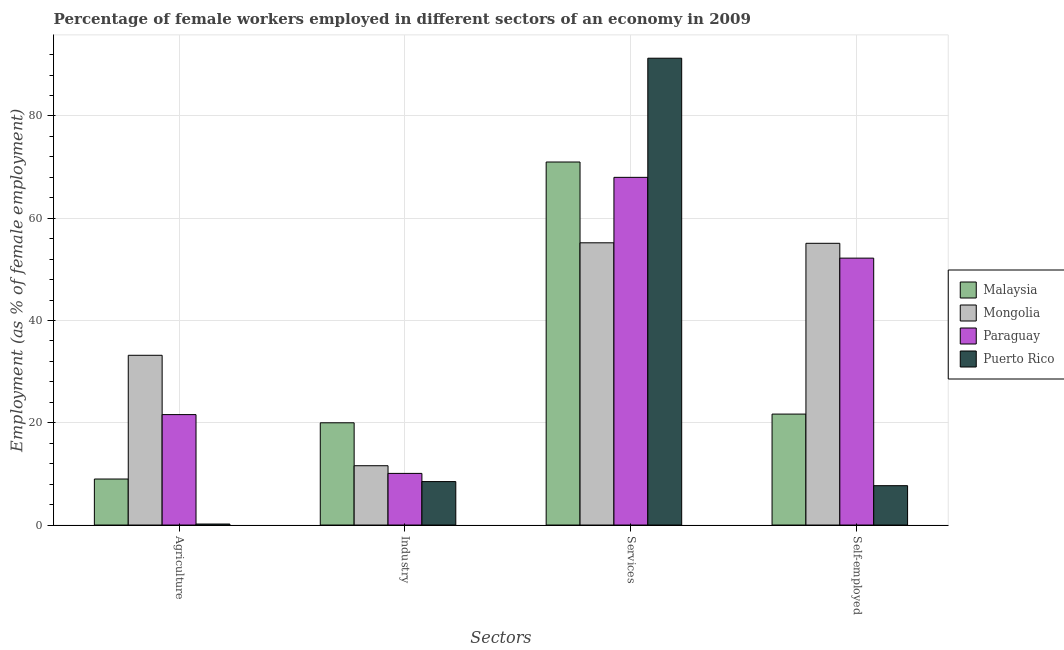How many groups of bars are there?
Offer a terse response. 4. Are the number of bars on each tick of the X-axis equal?
Offer a very short reply. Yes. How many bars are there on the 4th tick from the right?
Your answer should be very brief. 4. What is the label of the 4th group of bars from the left?
Ensure brevity in your answer.  Self-employed. Across all countries, what is the minimum percentage of self employed female workers?
Make the answer very short. 7.7. In which country was the percentage of self employed female workers maximum?
Your answer should be very brief. Mongolia. In which country was the percentage of self employed female workers minimum?
Provide a short and direct response. Puerto Rico. What is the total percentage of female workers in industry in the graph?
Offer a terse response. 50.2. What is the difference between the percentage of female workers in services in Paraguay and that in Puerto Rico?
Provide a succinct answer. -23.3. What is the difference between the percentage of female workers in services in Puerto Rico and the percentage of self employed female workers in Mongolia?
Provide a succinct answer. 36.2. What is the average percentage of female workers in services per country?
Make the answer very short. 71.38. What is the difference between the percentage of female workers in agriculture and percentage of female workers in services in Paraguay?
Provide a succinct answer. -46.4. What is the ratio of the percentage of self employed female workers in Malaysia to that in Mongolia?
Ensure brevity in your answer.  0.39. What is the difference between the highest and the second highest percentage of self employed female workers?
Your answer should be compact. 2.9. What is the difference between the highest and the lowest percentage of female workers in agriculture?
Provide a succinct answer. 33. What does the 3rd bar from the left in Industry represents?
Keep it short and to the point. Paraguay. What does the 4th bar from the right in Self-employed represents?
Offer a terse response. Malaysia. Is it the case that in every country, the sum of the percentage of female workers in agriculture and percentage of female workers in industry is greater than the percentage of female workers in services?
Offer a terse response. No. How many bars are there?
Offer a very short reply. 16. What is the difference between two consecutive major ticks on the Y-axis?
Offer a terse response. 20. Are the values on the major ticks of Y-axis written in scientific E-notation?
Your response must be concise. No. What is the title of the graph?
Your answer should be very brief. Percentage of female workers employed in different sectors of an economy in 2009. What is the label or title of the X-axis?
Your response must be concise. Sectors. What is the label or title of the Y-axis?
Give a very brief answer. Employment (as % of female employment). What is the Employment (as % of female employment) of Mongolia in Agriculture?
Offer a very short reply. 33.2. What is the Employment (as % of female employment) of Paraguay in Agriculture?
Make the answer very short. 21.6. What is the Employment (as % of female employment) of Puerto Rico in Agriculture?
Provide a short and direct response. 0.2. What is the Employment (as % of female employment) in Mongolia in Industry?
Make the answer very short. 11.6. What is the Employment (as % of female employment) in Paraguay in Industry?
Offer a very short reply. 10.1. What is the Employment (as % of female employment) of Mongolia in Services?
Keep it short and to the point. 55.2. What is the Employment (as % of female employment) of Puerto Rico in Services?
Provide a short and direct response. 91.3. What is the Employment (as % of female employment) in Malaysia in Self-employed?
Offer a terse response. 21.7. What is the Employment (as % of female employment) of Mongolia in Self-employed?
Give a very brief answer. 55.1. What is the Employment (as % of female employment) in Paraguay in Self-employed?
Ensure brevity in your answer.  52.2. What is the Employment (as % of female employment) of Puerto Rico in Self-employed?
Your response must be concise. 7.7. Across all Sectors, what is the maximum Employment (as % of female employment) of Malaysia?
Make the answer very short. 71. Across all Sectors, what is the maximum Employment (as % of female employment) in Mongolia?
Your response must be concise. 55.2. Across all Sectors, what is the maximum Employment (as % of female employment) in Paraguay?
Keep it short and to the point. 68. Across all Sectors, what is the maximum Employment (as % of female employment) of Puerto Rico?
Provide a short and direct response. 91.3. Across all Sectors, what is the minimum Employment (as % of female employment) of Malaysia?
Provide a short and direct response. 9. Across all Sectors, what is the minimum Employment (as % of female employment) of Mongolia?
Offer a very short reply. 11.6. Across all Sectors, what is the minimum Employment (as % of female employment) in Paraguay?
Your response must be concise. 10.1. Across all Sectors, what is the minimum Employment (as % of female employment) in Puerto Rico?
Make the answer very short. 0.2. What is the total Employment (as % of female employment) of Malaysia in the graph?
Provide a short and direct response. 121.7. What is the total Employment (as % of female employment) in Mongolia in the graph?
Offer a terse response. 155.1. What is the total Employment (as % of female employment) of Paraguay in the graph?
Your response must be concise. 151.9. What is the total Employment (as % of female employment) of Puerto Rico in the graph?
Provide a succinct answer. 107.7. What is the difference between the Employment (as % of female employment) of Malaysia in Agriculture and that in Industry?
Ensure brevity in your answer.  -11. What is the difference between the Employment (as % of female employment) in Mongolia in Agriculture and that in Industry?
Offer a very short reply. 21.6. What is the difference between the Employment (as % of female employment) of Puerto Rico in Agriculture and that in Industry?
Your response must be concise. -8.3. What is the difference between the Employment (as % of female employment) of Malaysia in Agriculture and that in Services?
Your response must be concise. -62. What is the difference between the Employment (as % of female employment) of Paraguay in Agriculture and that in Services?
Offer a very short reply. -46.4. What is the difference between the Employment (as % of female employment) of Puerto Rico in Agriculture and that in Services?
Give a very brief answer. -91.1. What is the difference between the Employment (as % of female employment) of Malaysia in Agriculture and that in Self-employed?
Make the answer very short. -12.7. What is the difference between the Employment (as % of female employment) of Mongolia in Agriculture and that in Self-employed?
Make the answer very short. -21.9. What is the difference between the Employment (as % of female employment) in Paraguay in Agriculture and that in Self-employed?
Provide a short and direct response. -30.6. What is the difference between the Employment (as % of female employment) of Malaysia in Industry and that in Services?
Provide a succinct answer. -51. What is the difference between the Employment (as % of female employment) in Mongolia in Industry and that in Services?
Offer a very short reply. -43.6. What is the difference between the Employment (as % of female employment) of Paraguay in Industry and that in Services?
Keep it short and to the point. -57.9. What is the difference between the Employment (as % of female employment) in Puerto Rico in Industry and that in Services?
Give a very brief answer. -82.8. What is the difference between the Employment (as % of female employment) of Mongolia in Industry and that in Self-employed?
Provide a succinct answer. -43.5. What is the difference between the Employment (as % of female employment) in Paraguay in Industry and that in Self-employed?
Ensure brevity in your answer.  -42.1. What is the difference between the Employment (as % of female employment) of Puerto Rico in Industry and that in Self-employed?
Provide a succinct answer. 0.8. What is the difference between the Employment (as % of female employment) in Malaysia in Services and that in Self-employed?
Keep it short and to the point. 49.3. What is the difference between the Employment (as % of female employment) of Mongolia in Services and that in Self-employed?
Your response must be concise. 0.1. What is the difference between the Employment (as % of female employment) of Paraguay in Services and that in Self-employed?
Make the answer very short. 15.8. What is the difference between the Employment (as % of female employment) of Puerto Rico in Services and that in Self-employed?
Give a very brief answer. 83.6. What is the difference between the Employment (as % of female employment) in Malaysia in Agriculture and the Employment (as % of female employment) in Mongolia in Industry?
Keep it short and to the point. -2.6. What is the difference between the Employment (as % of female employment) of Mongolia in Agriculture and the Employment (as % of female employment) of Paraguay in Industry?
Ensure brevity in your answer.  23.1. What is the difference between the Employment (as % of female employment) of Mongolia in Agriculture and the Employment (as % of female employment) of Puerto Rico in Industry?
Make the answer very short. 24.7. What is the difference between the Employment (as % of female employment) in Paraguay in Agriculture and the Employment (as % of female employment) in Puerto Rico in Industry?
Offer a very short reply. 13.1. What is the difference between the Employment (as % of female employment) of Malaysia in Agriculture and the Employment (as % of female employment) of Mongolia in Services?
Your answer should be compact. -46.2. What is the difference between the Employment (as % of female employment) in Malaysia in Agriculture and the Employment (as % of female employment) in Paraguay in Services?
Your answer should be compact. -59. What is the difference between the Employment (as % of female employment) of Malaysia in Agriculture and the Employment (as % of female employment) of Puerto Rico in Services?
Offer a very short reply. -82.3. What is the difference between the Employment (as % of female employment) in Mongolia in Agriculture and the Employment (as % of female employment) in Paraguay in Services?
Keep it short and to the point. -34.8. What is the difference between the Employment (as % of female employment) of Mongolia in Agriculture and the Employment (as % of female employment) of Puerto Rico in Services?
Provide a short and direct response. -58.1. What is the difference between the Employment (as % of female employment) of Paraguay in Agriculture and the Employment (as % of female employment) of Puerto Rico in Services?
Ensure brevity in your answer.  -69.7. What is the difference between the Employment (as % of female employment) in Malaysia in Agriculture and the Employment (as % of female employment) in Mongolia in Self-employed?
Offer a terse response. -46.1. What is the difference between the Employment (as % of female employment) of Malaysia in Agriculture and the Employment (as % of female employment) of Paraguay in Self-employed?
Give a very brief answer. -43.2. What is the difference between the Employment (as % of female employment) in Mongolia in Agriculture and the Employment (as % of female employment) in Paraguay in Self-employed?
Ensure brevity in your answer.  -19. What is the difference between the Employment (as % of female employment) of Mongolia in Agriculture and the Employment (as % of female employment) of Puerto Rico in Self-employed?
Keep it short and to the point. 25.5. What is the difference between the Employment (as % of female employment) in Malaysia in Industry and the Employment (as % of female employment) in Mongolia in Services?
Keep it short and to the point. -35.2. What is the difference between the Employment (as % of female employment) in Malaysia in Industry and the Employment (as % of female employment) in Paraguay in Services?
Give a very brief answer. -48. What is the difference between the Employment (as % of female employment) of Malaysia in Industry and the Employment (as % of female employment) of Puerto Rico in Services?
Give a very brief answer. -71.3. What is the difference between the Employment (as % of female employment) in Mongolia in Industry and the Employment (as % of female employment) in Paraguay in Services?
Offer a terse response. -56.4. What is the difference between the Employment (as % of female employment) of Mongolia in Industry and the Employment (as % of female employment) of Puerto Rico in Services?
Ensure brevity in your answer.  -79.7. What is the difference between the Employment (as % of female employment) in Paraguay in Industry and the Employment (as % of female employment) in Puerto Rico in Services?
Offer a terse response. -81.2. What is the difference between the Employment (as % of female employment) in Malaysia in Industry and the Employment (as % of female employment) in Mongolia in Self-employed?
Make the answer very short. -35.1. What is the difference between the Employment (as % of female employment) in Malaysia in Industry and the Employment (as % of female employment) in Paraguay in Self-employed?
Your answer should be very brief. -32.2. What is the difference between the Employment (as % of female employment) in Malaysia in Industry and the Employment (as % of female employment) in Puerto Rico in Self-employed?
Your response must be concise. 12.3. What is the difference between the Employment (as % of female employment) in Mongolia in Industry and the Employment (as % of female employment) in Paraguay in Self-employed?
Provide a succinct answer. -40.6. What is the difference between the Employment (as % of female employment) in Mongolia in Industry and the Employment (as % of female employment) in Puerto Rico in Self-employed?
Your response must be concise. 3.9. What is the difference between the Employment (as % of female employment) of Paraguay in Industry and the Employment (as % of female employment) of Puerto Rico in Self-employed?
Offer a terse response. 2.4. What is the difference between the Employment (as % of female employment) in Malaysia in Services and the Employment (as % of female employment) in Puerto Rico in Self-employed?
Your response must be concise. 63.3. What is the difference between the Employment (as % of female employment) of Mongolia in Services and the Employment (as % of female employment) of Paraguay in Self-employed?
Provide a short and direct response. 3. What is the difference between the Employment (as % of female employment) of Mongolia in Services and the Employment (as % of female employment) of Puerto Rico in Self-employed?
Offer a very short reply. 47.5. What is the difference between the Employment (as % of female employment) of Paraguay in Services and the Employment (as % of female employment) of Puerto Rico in Self-employed?
Keep it short and to the point. 60.3. What is the average Employment (as % of female employment) of Malaysia per Sectors?
Your answer should be compact. 30.43. What is the average Employment (as % of female employment) of Mongolia per Sectors?
Ensure brevity in your answer.  38.77. What is the average Employment (as % of female employment) of Paraguay per Sectors?
Make the answer very short. 37.98. What is the average Employment (as % of female employment) of Puerto Rico per Sectors?
Make the answer very short. 26.93. What is the difference between the Employment (as % of female employment) of Malaysia and Employment (as % of female employment) of Mongolia in Agriculture?
Your answer should be very brief. -24.2. What is the difference between the Employment (as % of female employment) in Mongolia and Employment (as % of female employment) in Paraguay in Agriculture?
Your answer should be very brief. 11.6. What is the difference between the Employment (as % of female employment) of Mongolia and Employment (as % of female employment) of Puerto Rico in Agriculture?
Your answer should be compact. 33. What is the difference between the Employment (as % of female employment) in Paraguay and Employment (as % of female employment) in Puerto Rico in Agriculture?
Your answer should be compact. 21.4. What is the difference between the Employment (as % of female employment) in Malaysia and Employment (as % of female employment) in Puerto Rico in Industry?
Make the answer very short. 11.5. What is the difference between the Employment (as % of female employment) in Mongolia and Employment (as % of female employment) in Paraguay in Industry?
Keep it short and to the point. 1.5. What is the difference between the Employment (as % of female employment) in Mongolia and Employment (as % of female employment) in Puerto Rico in Industry?
Your response must be concise. 3.1. What is the difference between the Employment (as % of female employment) of Malaysia and Employment (as % of female employment) of Puerto Rico in Services?
Provide a short and direct response. -20.3. What is the difference between the Employment (as % of female employment) of Mongolia and Employment (as % of female employment) of Puerto Rico in Services?
Your answer should be very brief. -36.1. What is the difference between the Employment (as % of female employment) in Paraguay and Employment (as % of female employment) in Puerto Rico in Services?
Make the answer very short. -23.3. What is the difference between the Employment (as % of female employment) of Malaysia and Employment (as % of female employment) of Mongolia in Self-employed?
Make the answer very short. -33.4. What is the difference between the Employment (as % of female employment) of Malaysia and Employment (as % of female employment) of Paraguay in Self-employed?
Offer a terse response. -30.5. What is the difference between the Employment (as % of female employment) of Mongolia and Employment (as % of female employment) of Puerto Rico in Self-employed?
Give a very brief answer. 47.4. What is the difference between the Employment (as % of female employment) in Paraguay and Employment (as % of female employment) in Puerto Rico in Self-employed?
Your answer should be compact. 44.5. What is the ratio of the Employment (as % of female employment) in Malaysia in Agriculture to that in Industry?
Your answer should be very brief. 0.45. What is the ratio of the Employment (as % of female employment) of Mongolia in Agriculture to that in Industry?
Your answer should be compact. 2.86. What is the ratio of the Employment (as % of female employment) in Paraguay in Agriculture to that in Industry?
Your answer should be compact. 2.14. What is the ratio of the Employment (as % of female employment) of Puerto Rico in Agriculture to that in Industry?
Make the answer very short. 0.02. What is the ratio of the Employment (as % of female employment) of Malaysia in Agriculture to that in Services?
Keep it short and to the point. 0.13. What is the ratio of the Employment (as % of female employment) in Mongolia in Agriculture to that in Services?
Ensure brevity in your answer.  0.6. What is the ratio of the Employment (as % of female employment) of Paraguay in Agriculture to that in Services?
Ensure brevity in your answer.  0.32. What is the ratio of the Employment (as % of female employment) of Puerto Rico in Agriculture to that in Services?
Your answer should be very brief. 0. What is the ratio of the Employment (as % of female employment) in Malaysia in Agriculture to that in Self-employed?
Offer a terse response. 0.41. What is the ratio of the Employment (as % of female employment) of Mongolia in Agriculture to that in Self-employed?
Give a very brief answer. 0.6. What is the ratio of the Employment (as % of female employment) of Paraguay in Agriculture to that in Self-employed?
Provide a short and direct response. 0.41. What is the ratio of the Employment (as % of female employment) of Puerto Rico in Agriculture to that in Self-employed?
Give a very brief answer. 0.03. What is the ratio of the Employment (as % of female employment) in Malaysia in Industry to that in Services?
Your answer should be compact. 0.28. What is the ratio of the Employment (as % of female employment) of Mongolia in Industry to that in Services?
Ensure brevity in your answer.  0.21. What is the ratio of the Employment (as % of female employment) of Paraguay in Industry to that in Services?
Your answer should be very brief. 0.15. What is the ratio of the Employment (as % of female employment) of Puerto Rico in Industry to that in Services?
Offer a very short reply. 0.09. What is the ratio of the Employment (as % of female employment) in Malaysia in Industry to that in Self-employed?
Give a very brief answer. 0.92. What is the ratio of the Employment (as % of female employment) in Mongolia in Industry to that in Self-employed?
Ensure brevity in your answer.  0.21. What is the ratio of the Employment (as % of female employment) of Paraguay in Industry to that in Self-employed?
Keep it short and to the point. 0.19. What is the ratio of the Employment (as % of female employment) of Puerto Rico in Industry to that in Self-employed?
Offer a very short reply. 1.1. What is the ratio of the Employment (as % of female employment) in Malaysia in Services to that in Self-employed?
Keep it short and to the point. 3.27. What is the ratio of the Employment (as % of female employment) in Mongolia in Services to that in Self-employed?
Ensure brevity in your answer.  1. What is the ratio of the Employment (as % of female employment) in Paraguay in Services to that in Self-employed?
Provide a succinct answer. 1.3. What is the ratio of the Employment (as % of female employment) of Puerto Rico in Services to that in Self-employed?
Your answer should be compact. 11.86. What is the difference between the highest and the second highest Employment (as % of female employment) in Malaysia?
Make the answer very short. 49.3. What is the difference between the highest and the second highest Employment (as % of female employment) in Mongolia?
Your answer should be compact. 0.1. What is the difference between the highest and the second highest Employment (as % of female employment) of Puerto Rico?
Provide a succinct answer. 82.8. What is the difference between the highest and the lowest Employment (as % of female employment) in Mongolia?
Your answer should be very brief. 43.6. What is the difference between the highest and the lowest Employment (as % of female employment) in Paraguay?
Offer a very short reply. 57.9. What is the difference between the highest and the lowest Employment (as % of female employment) of Puerto Rico?
Offer a very short reply. 91.1. 